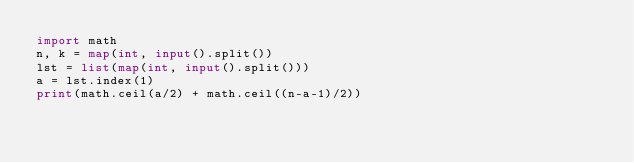Convert code to text. <code><loc_0><loc_0><loc_500><loc_500><_Python_>import math
n, k = map(int, input().split())
lst = list(map(int, input().split()))
a = lst.index(1)
print(math.ceil(a/2) + math.ceil((n-a-1)/2))</code> 